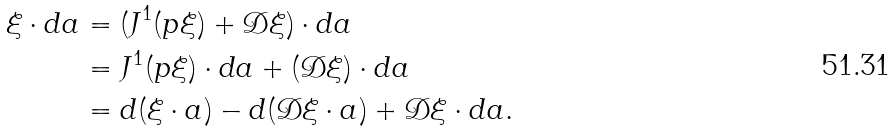<formula> <loc_0><loc_0><loc_500><loc_500>\xi \cdot d a & = ( J ^ { 1 } ( p \xi ) + { \mathcal { D } } \xi ) \cdot d a \\ & = J ^ { 1 } ( p \xi ) \cdot d a + ( { \mathcal { D } } \xi ) \cdot d a \\ & = d ( \xi \cdot a ) - d ( { \mathcal { D } } \xi \cdot a ) + { \mathcal { D } } \xi \cdot d a .</formula> 